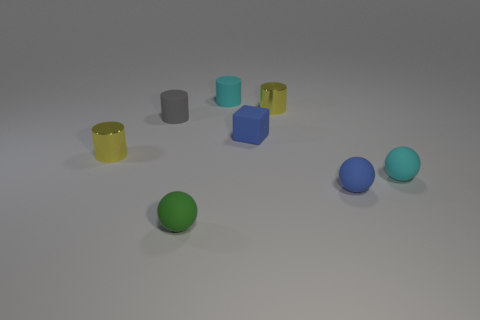There is a small cyan object that is the same shape as the gray thing; what material is it?
Provide a short and direct response. Rubber. The rubber block is what color?
Your answer should be compact. Blue. What number of metal objects are tiny gray objects or large gray blocks?
Your answer should be compact. 0. There is a yellow thing behind the yellow shiny cylinder on the left side of the cyan rubber cylinder; is there a small blue cube that is on the left side of it?
Your answer should be compact. Yes. Are there any blue matte things on the left side of the matte block?
Your answer should be very brief. No. Is there a cyan thing on the right side of the small matte object behind the small gray cylinder?
Make the answer very short. Yes. How many tiny things are either gray matte things or blue things?
Ensure brevity in your answer.  3. There is a yellow cylinder that is on the right side of the blue matte thing that is behind the tiny blue rubber ball; what is it made of?
Your answer should be very brief. Metal. The tiny matte object that is the same color as the matte cube is what shape?
Your answer should be very brief. Sphere. Are there any big cyan cylinders made of the same material as the tiny gray thing?
Offer a terse response. No. 